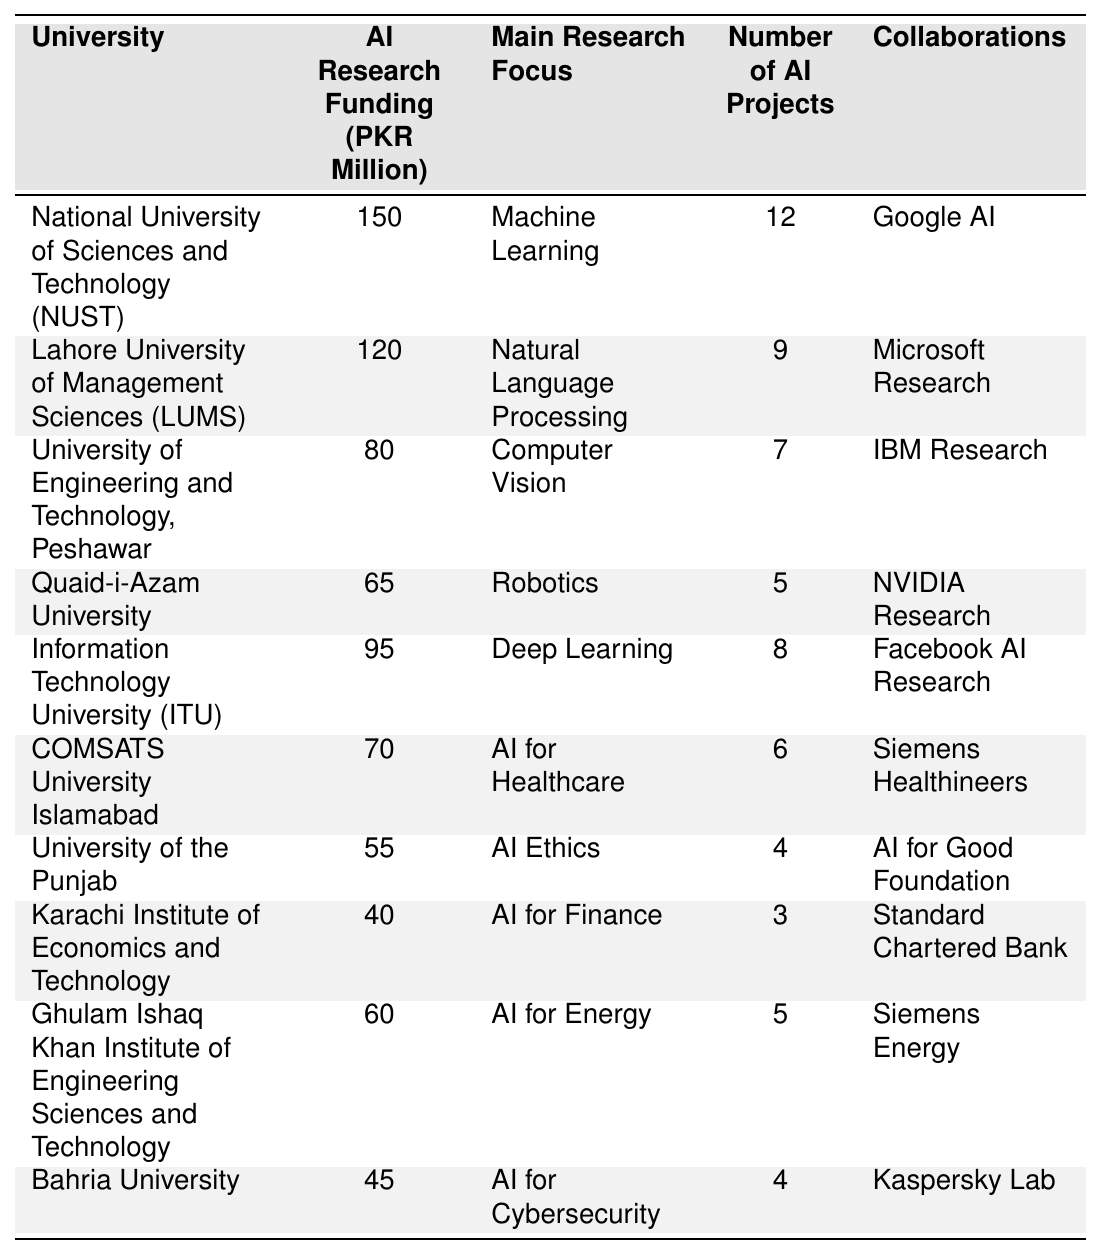What is the university with the highest AI research funding? The university with the highest funding can be found by looking at the "AI Research Funding" column and identifying the maximum value. The highest value is 150 million PKR, which is associated with the National University of Sciences and Technology (NUST).
Answer: National University of Sciences and Technology (NUST) How much funding does the Lahore University of Management Sciences (LUMS) receive for AI research? By locating the row for the Lahore University of Management Sciences in the table, the corresponding funding in the "AI Research Funding" column is 120 million PKR.
Answer: 120 million PKR What is the main research focus of the University of Engineering and Technology, Peshawar? The main research focus can be found by checking the "Main Research Focus" column for the specific row corresponding to the University of Engineering and Technology, Peshawar, which states "Computer Vision."
Answer: Computer Vision Which university has the least number of AI projects? To find out the university with the least number of AI projects, compare the "Number of AI Projects" column values and identify the minimum. The Karachi Institute of Economics and Technology has the least number at 3 projects.
Answer: Karachi Institute of Economics and Technology What is the total funding of universities focused on AI for Healthcare and AI for Cybersecurity? First, locate the funding for COMSATS University Islamabad (AI for Healthcare) which is 70 million PKR, and Bahria University (AI for Cybersecurity) which is 45 million PKR. Next, sum these values: 70 + 45 = 115 million PKR.
Answer: 115 million PKR Is the University of the Punjab collaborating with Microsoft Research? Check the "Collaborations" column for the University of the Punjab, which shows "AI for Good Foundation." Since it does not list Microsoft Research, the answer is no.
Answer: No How many total AI projects are conducted by the top three universities with the highest AI research funding? First, identify the top three universities by funding: NUST (12 projects), LUMS (9 projects), and the University of Engineering and Technology (7 projects). Add their project numbers together: 12 + 9 + 7 = 28 projects.
Answer: 28 projects Which university has a focus on AI Ethics and how many projects do they have? Review the table for the entry on the University of the Punjab which focuses on AI Ethics and has 4 projects listed.
Answer: University of the Punjab, 4 projects What is the average AI research funding of the universities listed in the table? Add all funding values: 150 + 120 + 80 + 65 + 95 + 70 + 55 + 40 + 60 + 45 = 1,080 million PKR. There are 10 universities, so divide to find the average: 1,080 / 10 = 108 million PKR.
Answer: 108 million PKR How many collaborations does Ghulam Ishaq Khan Institute of Engineering Sciences and Technology have? Directly check the "Collaborations" column for Ghulam Ishaq Khan Institute, which lists 5 collaborations with Siemens Energy.
Answer: 5 collaborations 